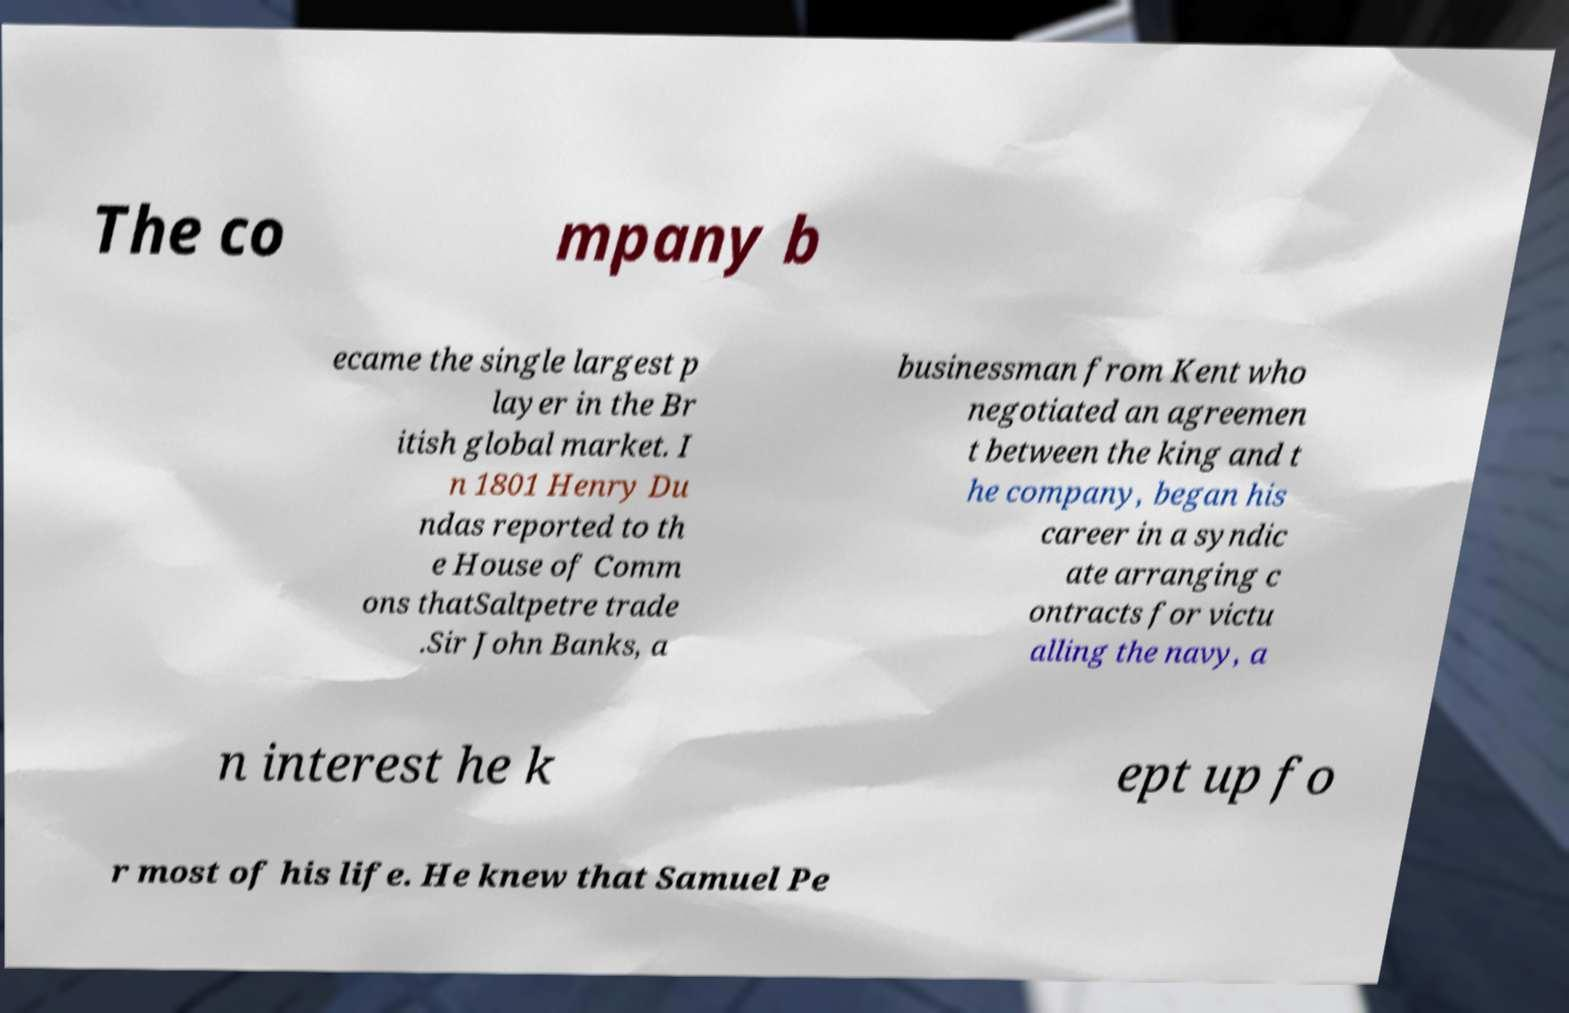Could you assist in decoding the text presented in this image and type it out clearly? The co mpany b ecame the single largest p layer in the Br itish global market. I n 1801 Henry Du ndas reported to th e House of Comm ons thatSaltpetre trade .Sir John Banks, a businessman from Kent who negotiated an agreemen t between the king and t he company, began his career in a syndic ate arranging c ontracts for victu alling the navy, a n interest he k ept up fo r most of his life. He knew that Samuel Pe 